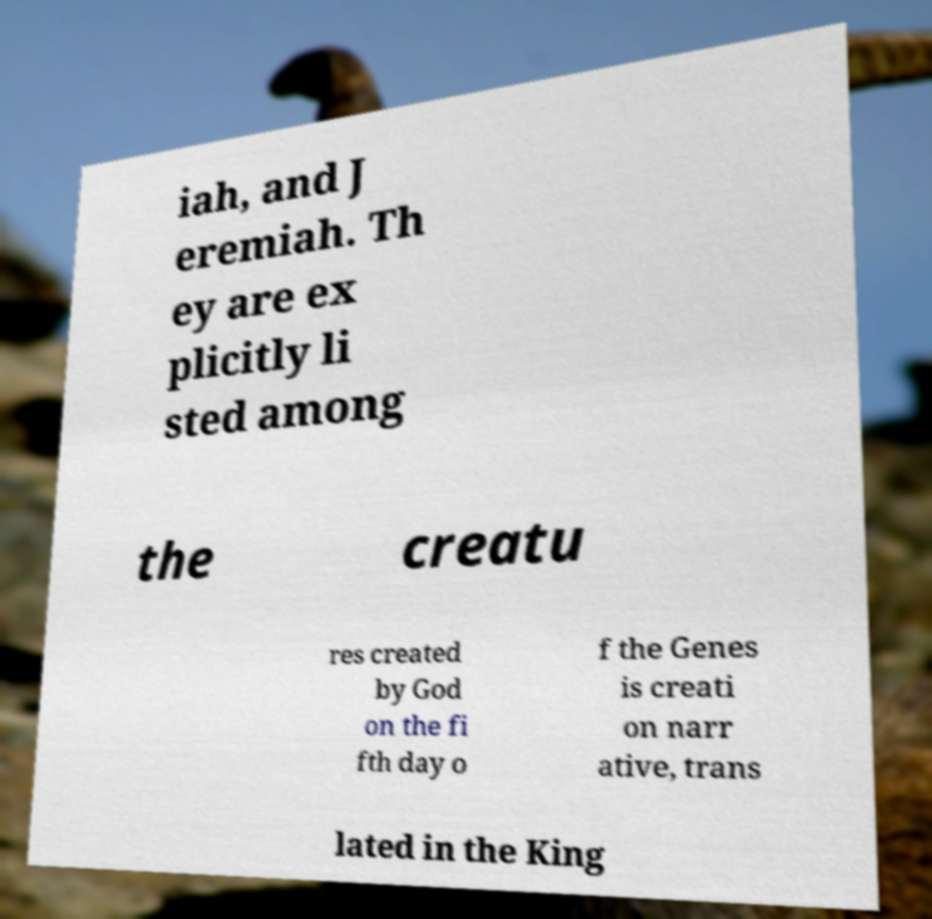There's text embedded in this image that I need extracted. Can you transcribe it verbatim? iah, and J eremiah. Th ey are ex plicitly li sted among the creatu res created by God on the fi fth day o f the Genes is creati on narr ative, trans lated in the King 